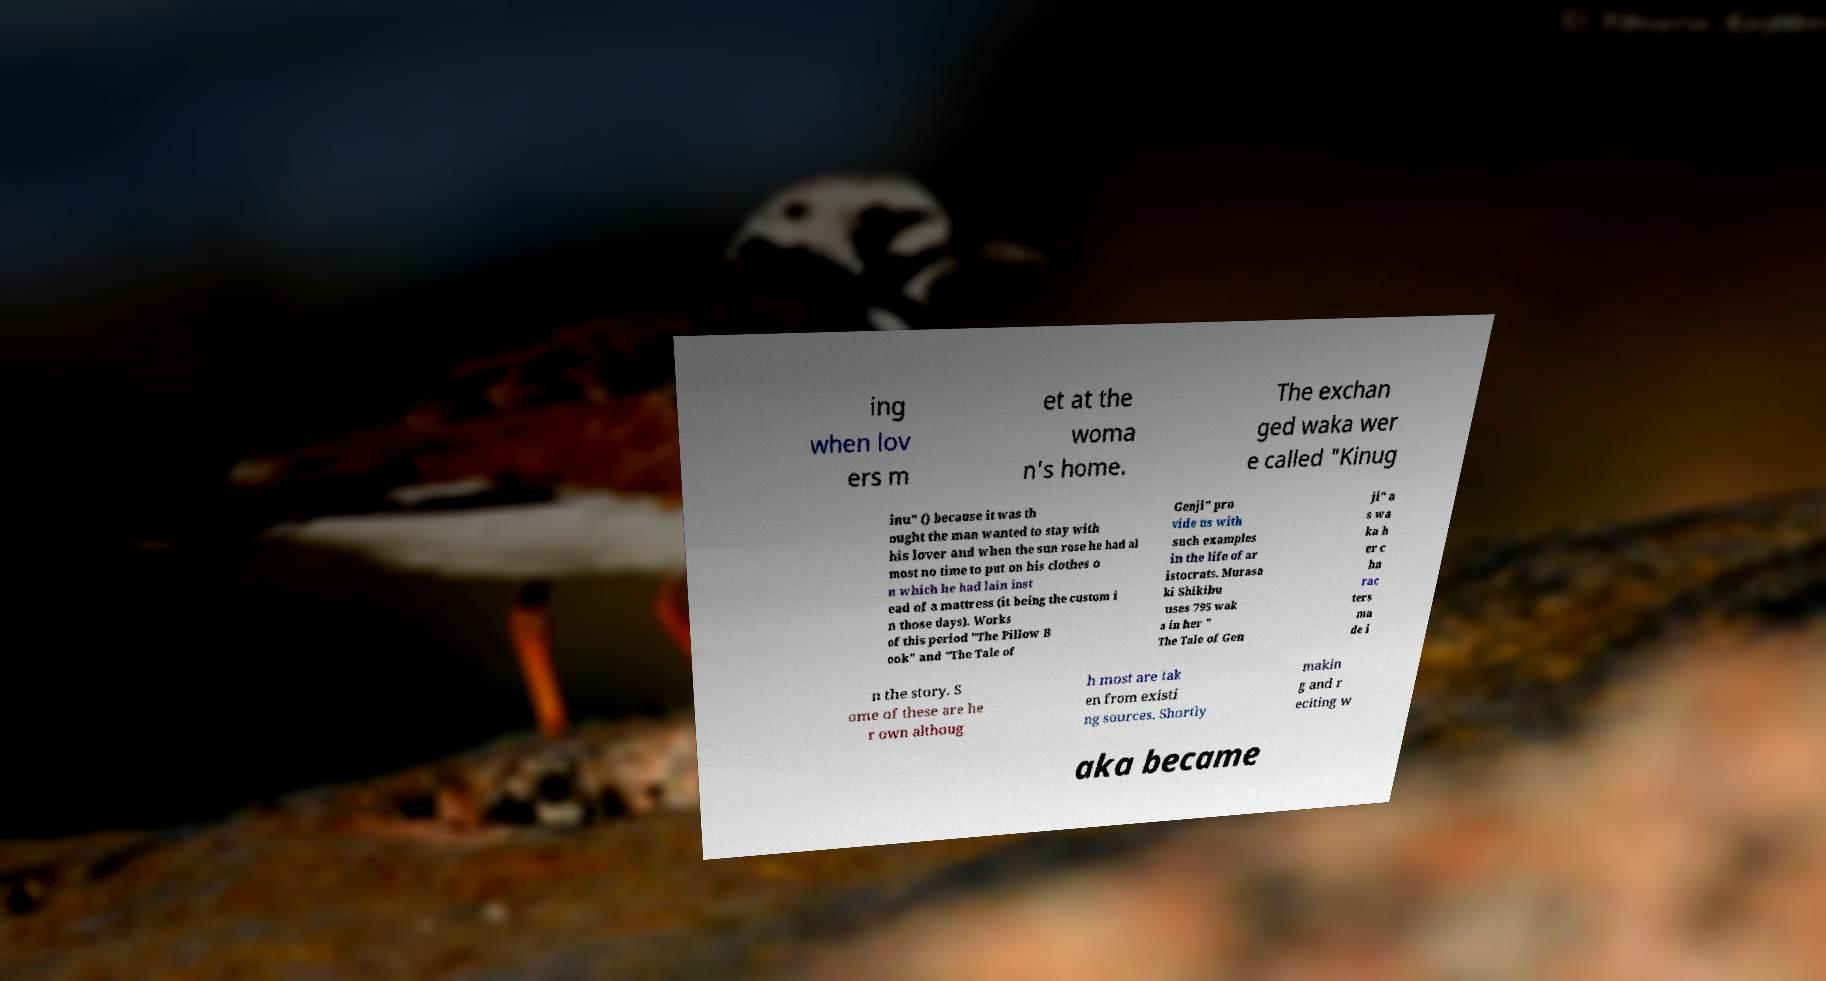What messages or text are displayed in this image? I need them in a readable, typed format. ing when lov ers m et at the woma n's home. The exchan ged waka wer e called "Kinug inu" () because it was th ought the man wanted to stay with his lover and when the sun rose he had al most no time to put on his clothes o n which he had lain inst ead of a mattress (it being the custom i n those days). Works of this period "The Pillow B ook" and "The Tale of Genji" pro vide us with such examples in the life of ar istocrats. Murasa ki Shikibu uses 795 wak a in her " The Tale of Gen ji" a s wa ka h er c ha rac ters ma de i n the story. S ome of these are he r own althoug h most are tak en from existi ng sources. Shortly makin g and r eciting w aka became 